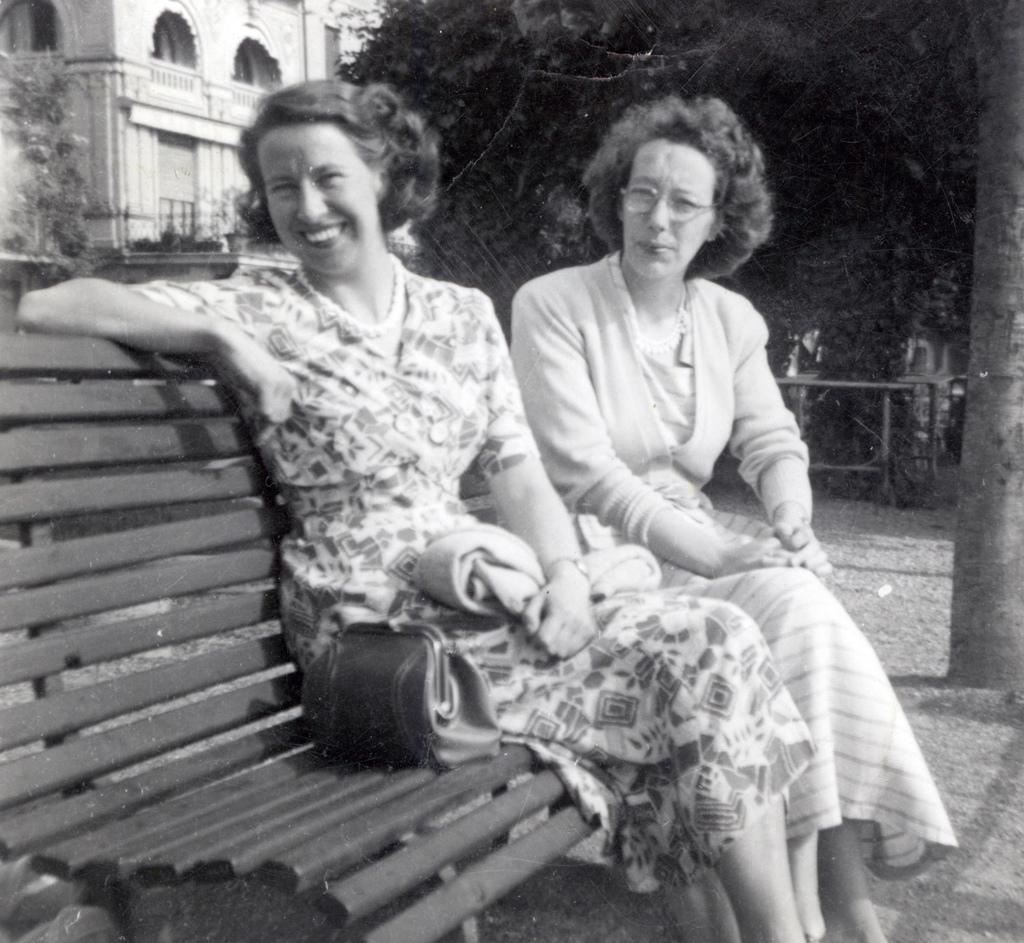How would you summarize this image in a sentence or two? This is a black and white image. In the center of the image we can see women sitting on the bench. In the background we can see trees and building. 